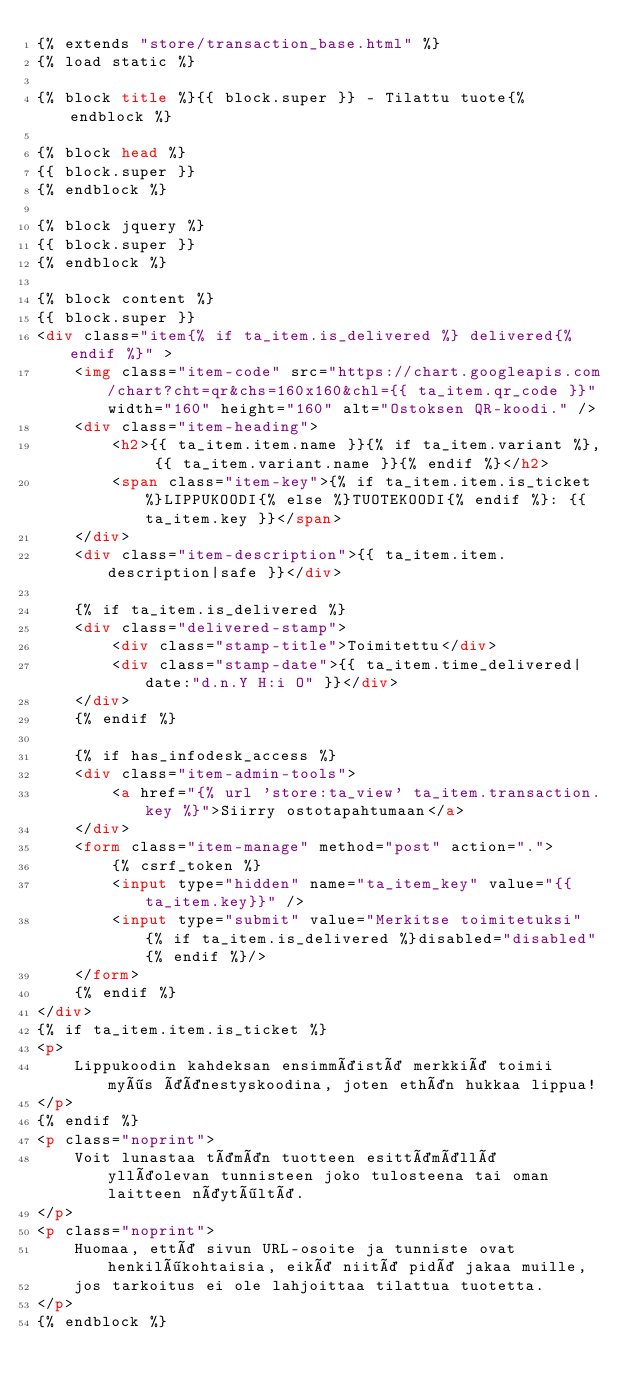<code> <loc_0><loc_0><loc_500><loc_500><_HTML_>{% extends "store/transaction_base.html" %}
{% load static %}

{% block title %}{{ block.super }} - Tilattu tuote{% endblock %}

{% block head %}
{{ block.super }}
{% endblock %}

{% block jquery %}
{{ block.super }}
{% endblock %}

{% block content %}
{{ block.super }}
<div class="item{% if ta_item.is_delivered %} delivered{% endif %}" >
    <img class="item-code" src="https://chart.googleapis.com/chart?cht=qr&chs=160x160&chl={{ ta_item.qr_code }}" width="160" height="160" alt="Ostoksen QR-koodi." />
    <div class="item-heading">
        <h2>{{ ta_item.item.name }}{% if ta_item.variant %}, {{ ta_item.variant.name }}{% endif %}</h2>
        <span class="item-key">{% if ta_item.item.is_ticket %}LIPPUKOODI{% else %}TUOTEKOODI{% endif %}: {{ ta_item.key }}</span>
    </div>
    <div class="item-description">{{ ta_item.item.description|safe }}</div>

    {% if ta_item.is_delivered %}
    <div class="delivered-stamp">
        <div class="stamp-title">Toimitettu</div>
        <div class="stamp-date">{{ ta_item.time_delivered|date:"d.n.Y H:i O" }}</div>
    </div>
    {% endif %}

    {% if has_infodesk_access %}
    <div class="item-admin-tools">
        <a href="{% url 'store:ta_view' ta_item.transaction.key %}">Siirry ostotapahtumaan</a>
    </div>
    <form class="item-manage" method="post" action=".">
        {% csrf_token %}
        <input type="hidden" name="ta_item_key" value="{{ta_item.key}}" />
        <input type="submit" value="Merkitse toimitetuksi" {% if ta_item.is_delivered %}disabled="disabled"{% endif %}/>
    </form>
    {% endif %}
</div>
{% if ta_item.item.is_ticket %}
<p>
    Lippukoodin kahdeksan ensimmäistä merkkiä toimii myös äänestyskoodina, joten ethän hukkaa lippua!
</p>
{% endif %}
<p class="noprint">
    Voit lunastaa tämän tuotteen esittämällä ylläolevan tunnisteen joko tulosteena tai oman laitteen näytöltä.
</p>
<p class="noprint">
    Huomaa, että sivun URL-osoite ja tunniste ovat henkilökohtaisia, eikä niitä pidä jakaa muille,
    jos tarkoitus ei ole lahjoittaa tilattua tuotetta.
</p>
{% endblock %}
</code> 